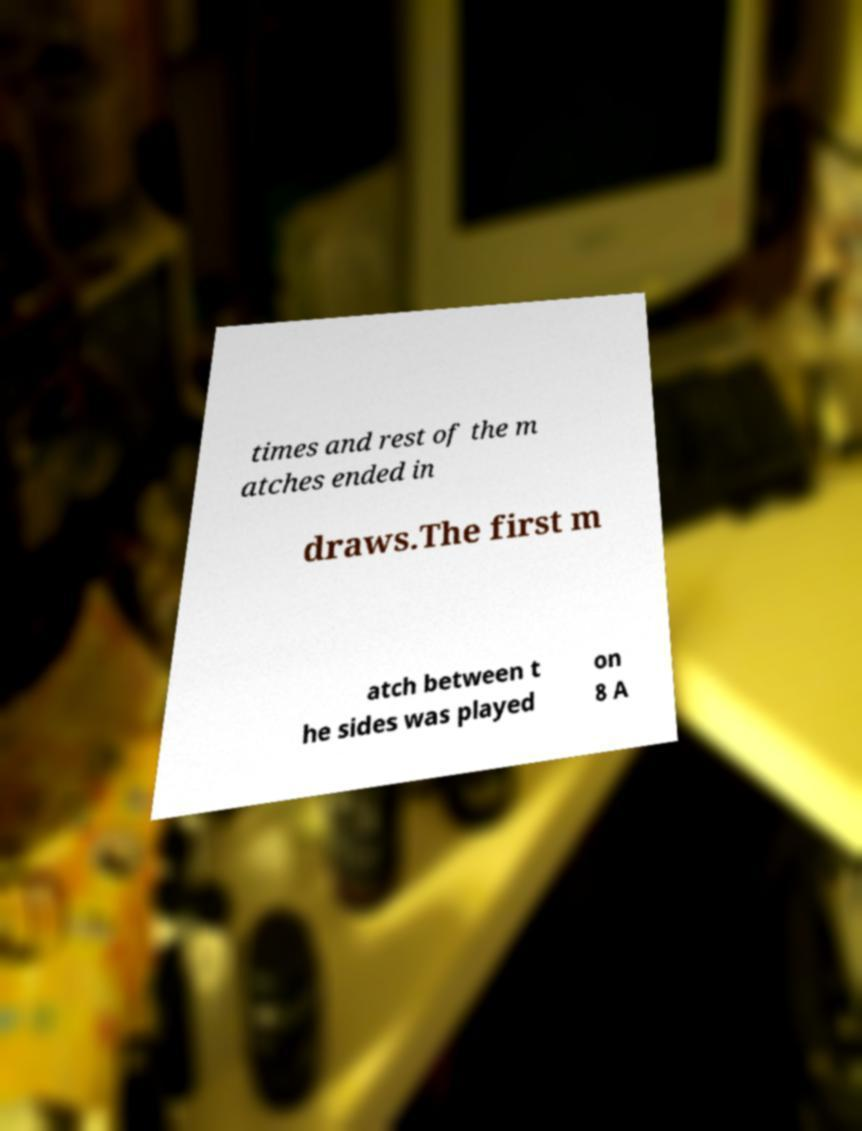Could you assist in decoding the text presented in this image and type it out clearly? times and rest of the m atches ended in draws.The first m atch between t he sides was played on 8 A 